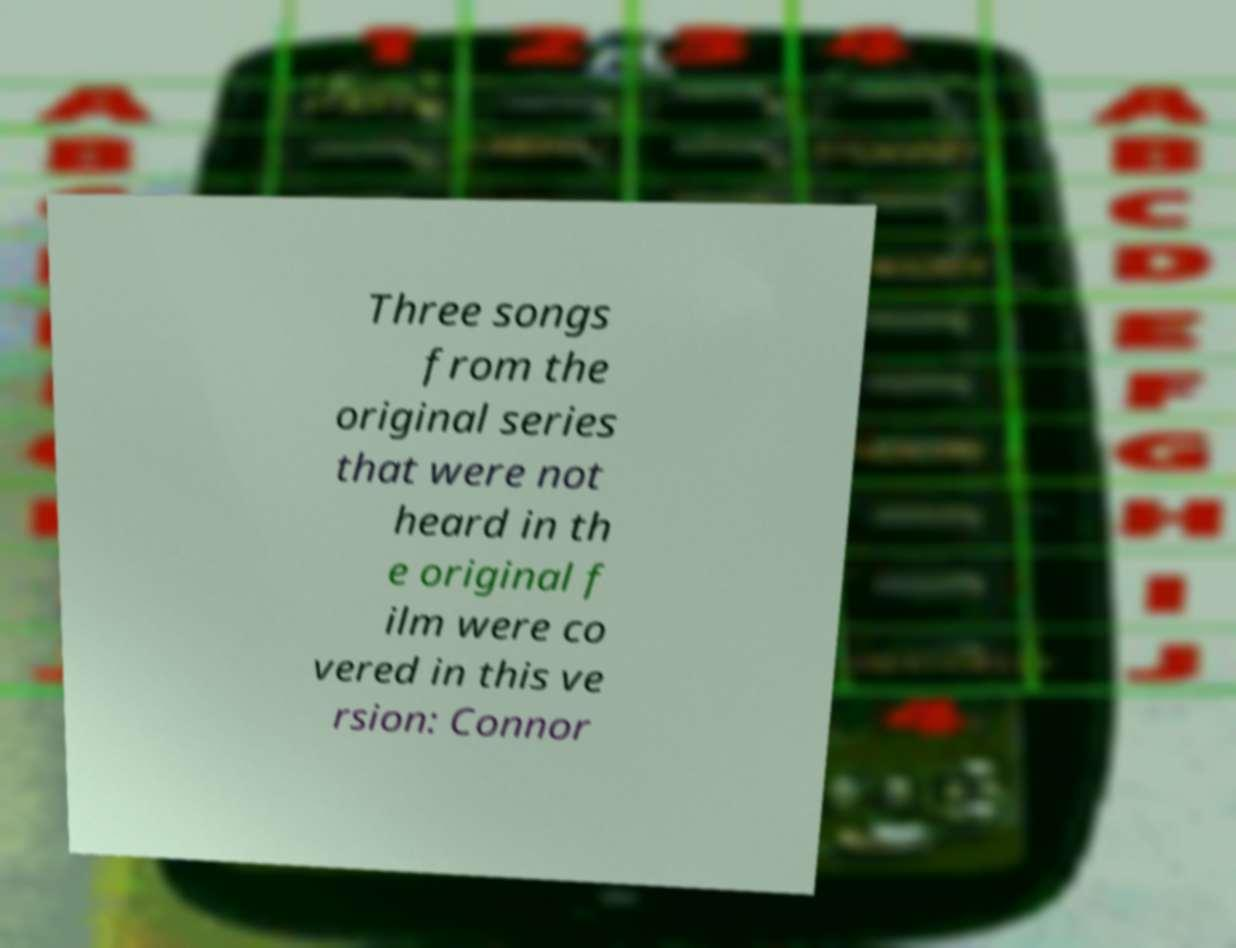Please identify and transcribe the text found in this image. Three songs from the original series that were not heard in th e original f ilm were co vered in this ve rsion: Connor 